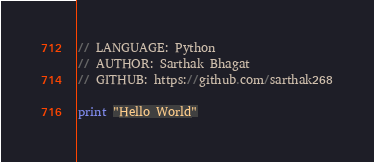<code> <loc_0><loc_0><loc_500><loc_500><_Python_>// LANGUAGE: Python
// AUTHOR: Sarthak Bhagat
// GITHUB: https://github.com/sarthak268

print "Hello World"
</code> 